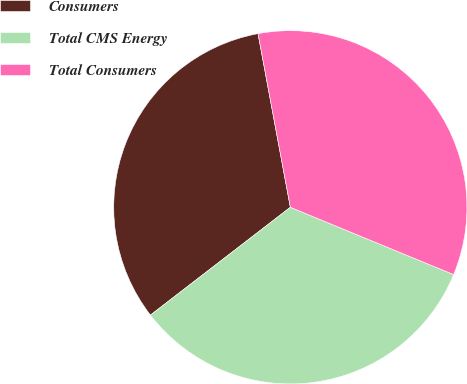Convert chart to OTSL. <chart><loc_0><loc_0><loc_500><loc_500><pie_chart><fcel>Consumers<fcel>Total CMS Energy<fcel>Total Consumers<nl><fcel>32.52%<fcel>33.33%<fcel>34.15%<nl></chart> 